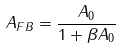Convert formula to latex. <formula><loc_0><loc_0><loc_500><loc_500>A _ { F B } = \frac { A _ { 0 } } { 1 + \beta A _ { 0 } }</formula> 